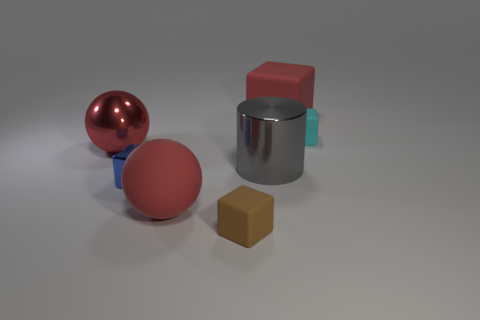Subtract all large red blocks. How many blocks are left? 3 Add 1 cyan rubber cubes. How many objects exist? 8 Subtract all red blocks. How many blocks are left? 3 Subtract 1 balls. How many balls are left? 1 Subtract all brown cylinders. Subtract all blue blocks. How many cylinders are left? 1 Subtract all cyan blocks. How many green spheres are left? 0 Subtract all red shiny spheres. Subtract all blue metallic cubes. How many objects are left? 5 Add 1 cyan matte objects. How many cyan matte objects are left? 2 Add 6 small blocks. How many small blocks exist? 9 Subtract 0 cyan cylinders. How many objects are left? 7 